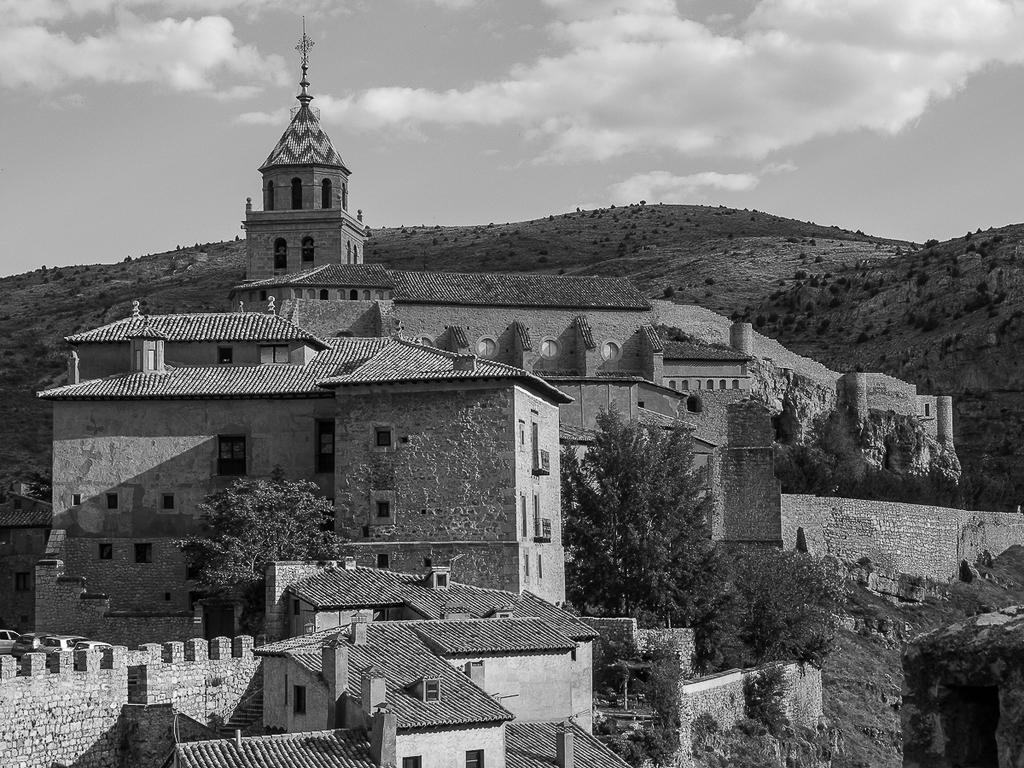What is the color scheme of the image? The image is black and white. What type of structures can be seen in the image? There are buildings in the image. What type of vegetation is present in the image? There are plants and trees in the image. What type of natural feature can be seen in the image? There are rocks in the image. What is visible at the top of the image? The sky is visible at the top of the image. What type of pancake is being served on the table in the image? There is no table or pancake present in the image; it features a black and white scene with buildings, plants, trees, rocks, and a visible sky. Can you tell me how many shakes are being consumed by the people in the image? There are no people or shakes present in the image. 